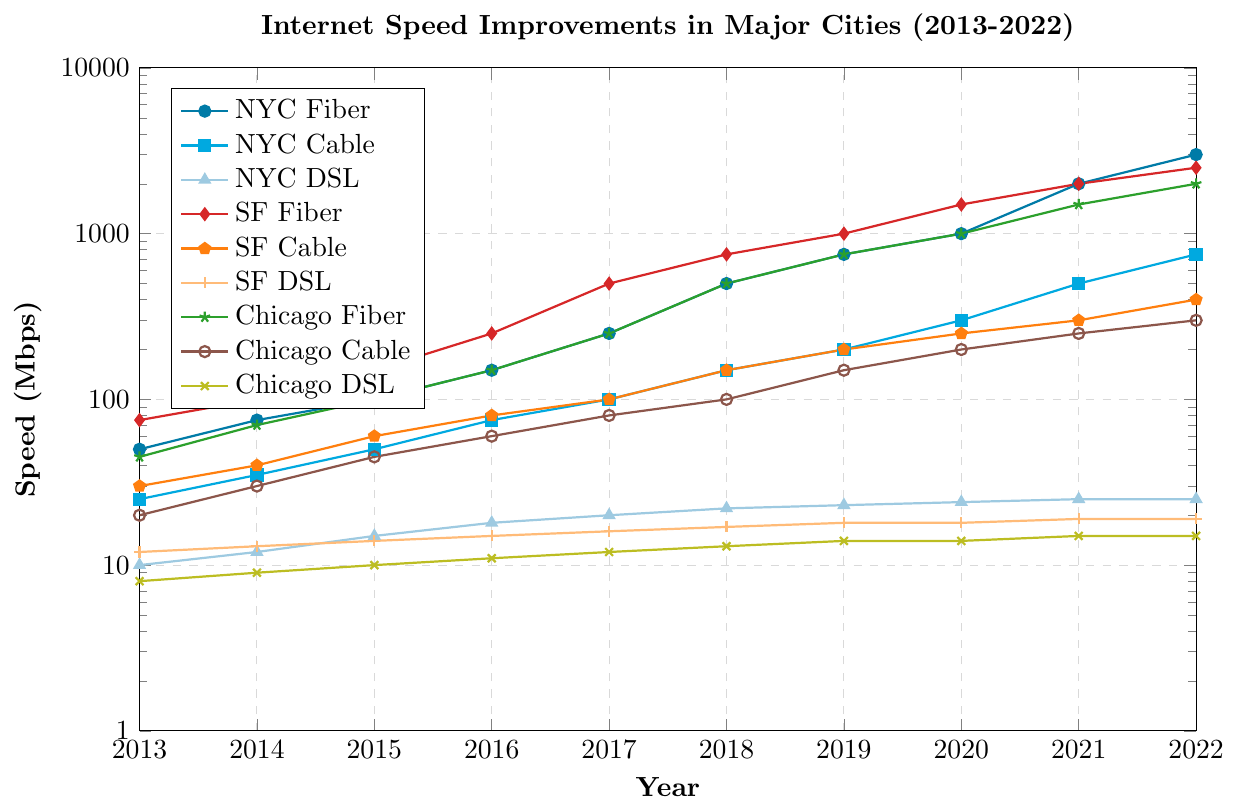Which city saw the highest internet speed for fiber connections in 2022? In the plot, the line representing San Francisco Fiber in 2022 is the highest, reaching a speed of 2500 Mbps.
Answer: San Francisco How did the internet speed for NYC DSL change from 2013 to 2022? The NYC DSL speed went from 10 Mbps in 2013 to 25 Mbps in 2022, increasing step-by-step each year until it remained constant from 2021.
Answer: Increased by 15 Mbps Which type of internet connection had the most significant improvement in New York City from 2013 to 2022? Fiber internet in NYC increased from 50 Mbps in 2013 to 3000 Mbps in 2022, marking the largest improvement among all connection types.
Answer: NYC Fiber Compare the 2022 internet speed of Chicago Cable and SF Cable. In 2022, Chicago Cable reached 300 Mbps while SF Cable reached 400 Mbps, so SF Cable had a higher speed.
Answer: SF Cable What is the average internet speed for SF DSL from 2013 to 2022? To find the average, sum the speeds from 2013 to 2022 and divide by the number of years. Sum: 12+13+14+15+16+17+18+18+19+19 = 161. Average: 161/10 = 16.1 Mbps.
Answer: 16.1 Mbps Which city's fiber internet reached 500 Mbps first, and in what year? San Francisco Fiber hit 500 Mbps in 2017, before New York City and Chicago reached the same speed.
Answer: San Francisco, 2017 What is the difference in 2022 internet speeds between the fastest and the slowest connection types in Chicago? In 2022, Chicago Fiber was the fastest connection at 2000 Mbps, and Chicago DSL was the slowest at 15 Mbps. The difference is 2000 - 15 = 1985 Mbps.
Answer: 1985 Mbps Which internet connection type had the least improvement in speed across all cities from 2013 to 2022? The DSL connection type in all cities improved the least, with NYC DSL increasing by 15 Mbps, SF DSL by 7 Mbps, and Chicago DSL by 7 Mbps over the decade.
Answer: DSL By how much did San Francisco Fiber outpace New York City Fiber in terms of internet speed in 2019? San Francisco Fiber reached 1000 Mbps in 2019, whereas New York City Fiber clocked at 750 Mbps, making the difference 1000 - 750 = 250 Mbps.
Answer: 250 Mbps Between 2017 and 2020, which city saw the fastest improvement in cable internet speed? From 2017 to 2020, NYC Cable improved from 100 Mbps to 300 Mbps (200 Mbps increase), SF Cable from 100 Mbps to 250 Mbps (150 Mbps increase), and Chicago Cable from 80 Mbps to 200 Mbps (120 Mbps increase). Therefore, NYC saw the fastest improvement.
Answer: New York City 